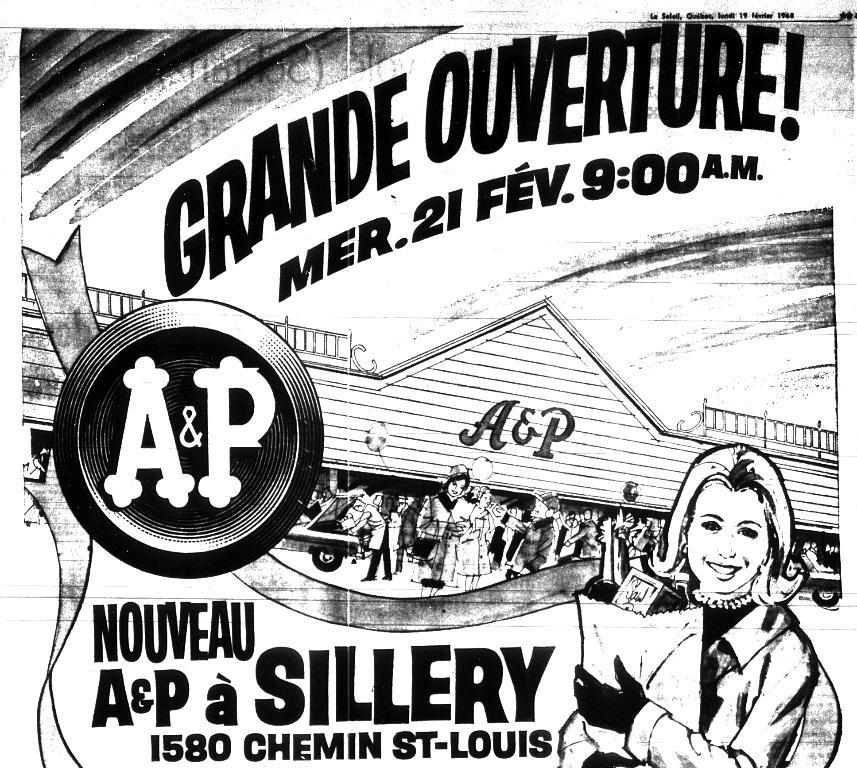What is the color scheme of the image? The image is black and white. What can be seen on the poster in the image? There is a poster in the image that contains images and text. Can you tell me how many giraffes are drinking water from the body of water in the image? There are no giraffes or bodies of water present in the image; it features a black and white poster with images and text. 